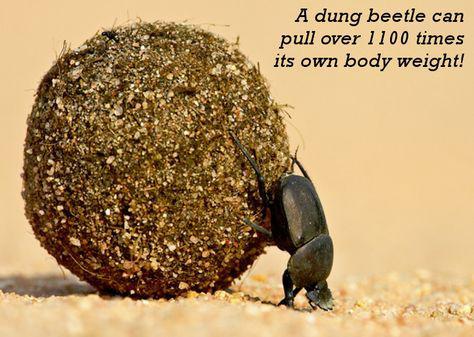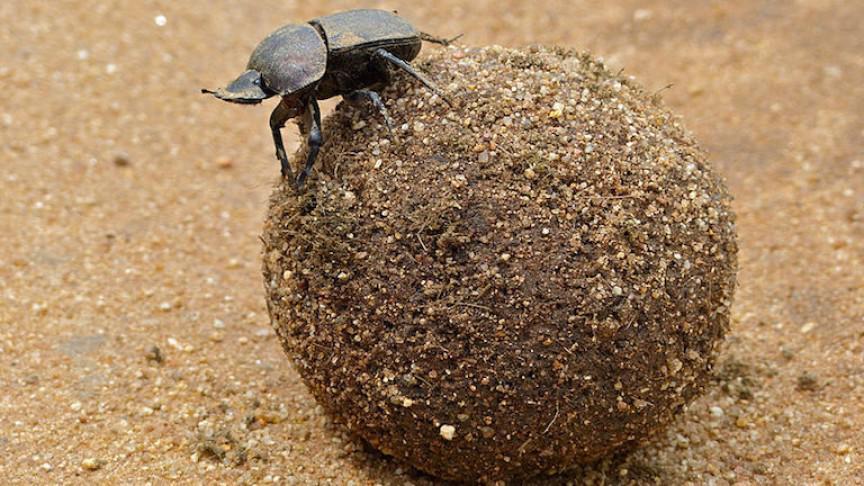The first image is the image on the left, the second image is the image on the right. Given the left and right images, does the statement "There are two dung beetles in the image on the right." hold true? Answer yes or no. No. The first image is the image on the left, the second image is the image on the right. Analyze the images presented: Is the assertion "There are at least three beetles." valid? Answer yes or no. No. 